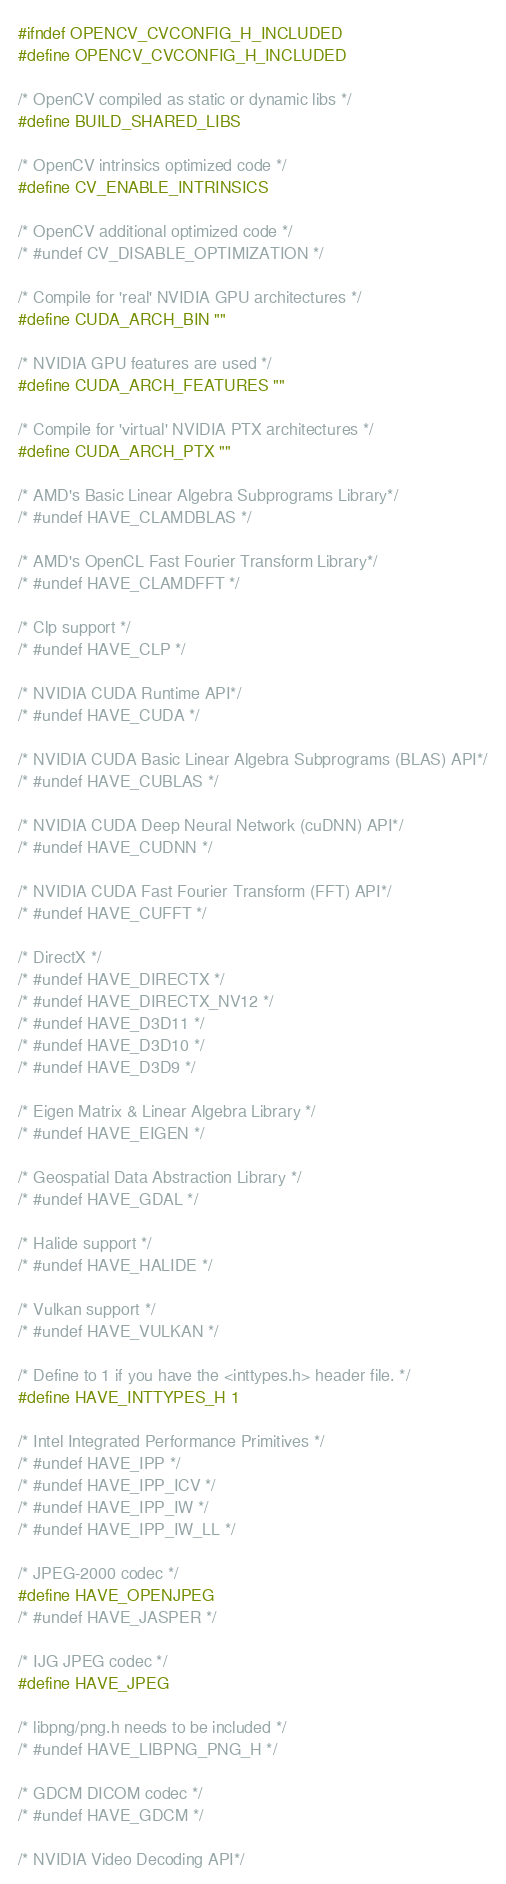Convert code to text. <code><loc_0><loc_0><loc_500><loc_500><_C_>#ifndef OPENCV_CVCONFIG_H_INCLUDED
#define OPENCV_CVCONFIG_H_INCLUDED

/* OpenCV compiled as static or dynamic libs */
#define BUILD_SHARED_LIBS

/* OpenCV intrinsics optimized code */
#define CV_ENABLE_INTRINSICS

/* OpenCV additional optimized code */
/* #undef CV_DISABLE_OPTIMIZATION */

/* Compile for 'real' NVIDIA GPU architectures */
#define CUDA_ARCH_BIN ""

/* NVIDIA GPU features are used */
#define CUDA_ARCH_FEATURES ""

/* Compile for 'virtual' NVIDIA PTX architectures */
#define CUDA_ARCH_PTX ""

/* AMD's Basic Linear Algebra Subprograms Library*/
/* #undef HAVE_CLAMDBLAS */

/* AMD's OpenCL Fast Fourier Transform Library*/
/* #undef HAVE_CLAMDFFT */

/* Clp support */
/* #undef HAVE_CLP */

/* NVIDIA CUDA Runtime API*/
/* #undef HAVE_CUDA */

/* NVIDIA CUDA Basic Linear Algebra Subprograms (BLAS) API*/
/* #undef HAVE_CUBLAS */

/* NVIDIA CUDA Deep Neural Network (cuDNN) API*/
/* #undef HAVE_CUDNN */

/* NVIDIA CUDA Fast Fourier Transform (FFT) API*/
/* #undef HAVE_CUFFT */

/* DirectX */
/* #undef HAVE_DIRECTX */
/* #undef HAVE_DIRECTX_NV12 */
/* #undef HAVE_D3D11 */
/* #undef HAVE_D3D10 */
/* #undef HAVE_D3D9 */

/* Eigen Matrix & Linear Algebra Library */
/* #undef HAVE_EIGEN */

/* Geospatial Data Abstraction Library */
/* #undef HAVE_GDAL */

/* Halide support */
/* #undef HAVE_HALIDE */

/* Vulkan support */
/* #undef HAVE_VULKAN */

/* Define to 1 if you have the <inttypes.h> header file. */
#define HAVE_INTTYPES_H 1

/* Intel Integrated Performance Primitives */
/* #undef HAVE_IPP */
/* #undef HAVE_IPP_ICV */
/* #undef HAVE_IPP_IW */
/* #undef HAVE_IPP_IW_LL */

/* JPEG-2000 codec */
#define HAVE_OPENJPEG
/* #undef HAVE_JASPER */

/* IJG JPEG codec */
#define HAVE_JPEG

/* libpng/png.h needs to be included */
/* #undef HAVE_LIBPNG_PNG_H */

/* GDCM DICOM codec */
/* #undef HAVE_GDCM */

/* NVIDIA Video Decoding API*/</code> 